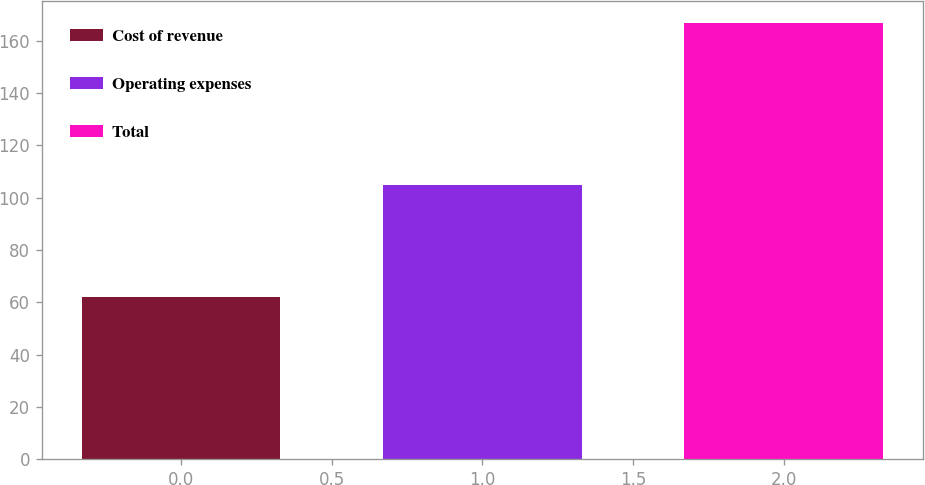Convert chart to OTSL. <chart><loc_0><loc_0><loc_500><loc_500><bar_chart><fcel>Cost of revenue<fcel>Operating expenses<fcel>Total<nl><fcel>62<fcel>104.9<fcel>166.9<nl></chart> 